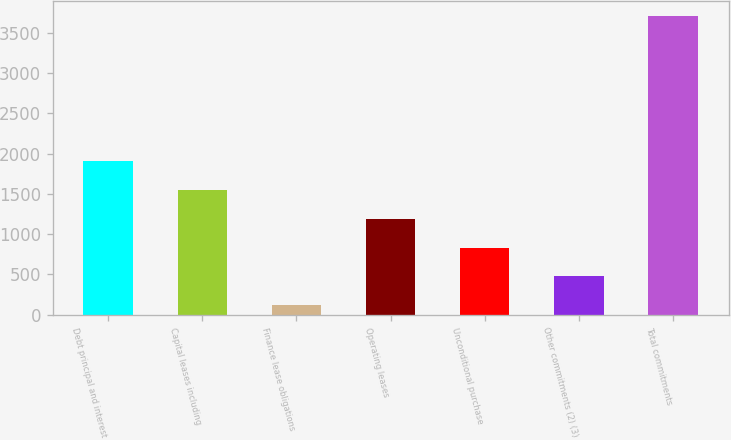<chart> <loc_0><loc_0><loc_500><loc_500><bar_chart><fcel>Debt principal and interest<fcel>Capital leases including<fcel>Finance lease obligations<fcel>Operating leases<fcel>Unconditional purchase<fcel>Other commitments (2) (3)<fcel>Total commitments<nl><fcel>1910.5<fcel>1551.4<fcel>115<fcel>1192.3<fcel>833.2<fcel>474.1<fcel>3706<nl></chart> 